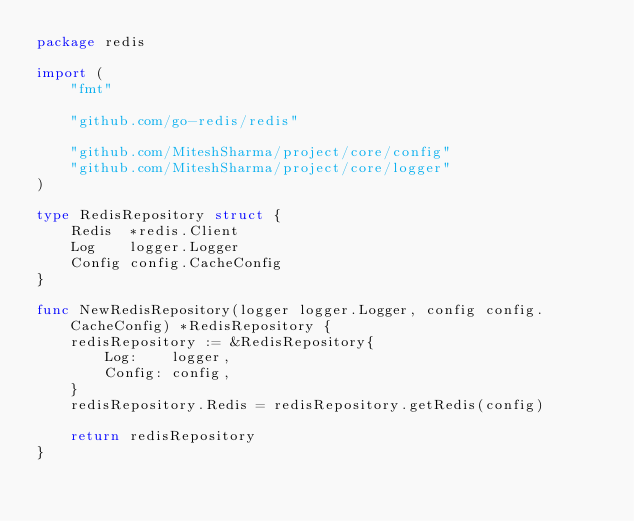<code> <loc_0><loc_0><loc_500><loc_500><_Go_>package redis

import (
	"fmt"

	"github.com/go-redis/redis"

	"github.com/MiteshSharma/project/core/config"
	"github.com/MiteshSharma/project/core/logger"
)

type RedisRepository struct {
	Redis  *redis.Client
	Log    logger.Logger
	Config config.CacheConfig
}

func NewRedisRepository(logger logger.Logger, config config.CacheConfig) *RedisRepository {
	redisRepository := &RedisRepository{
		Log:    logger,
		Config: config,
	}
	redisRepository.Redis = redisRepository.getRedis(config)

	return redisRepository
}
</code> 